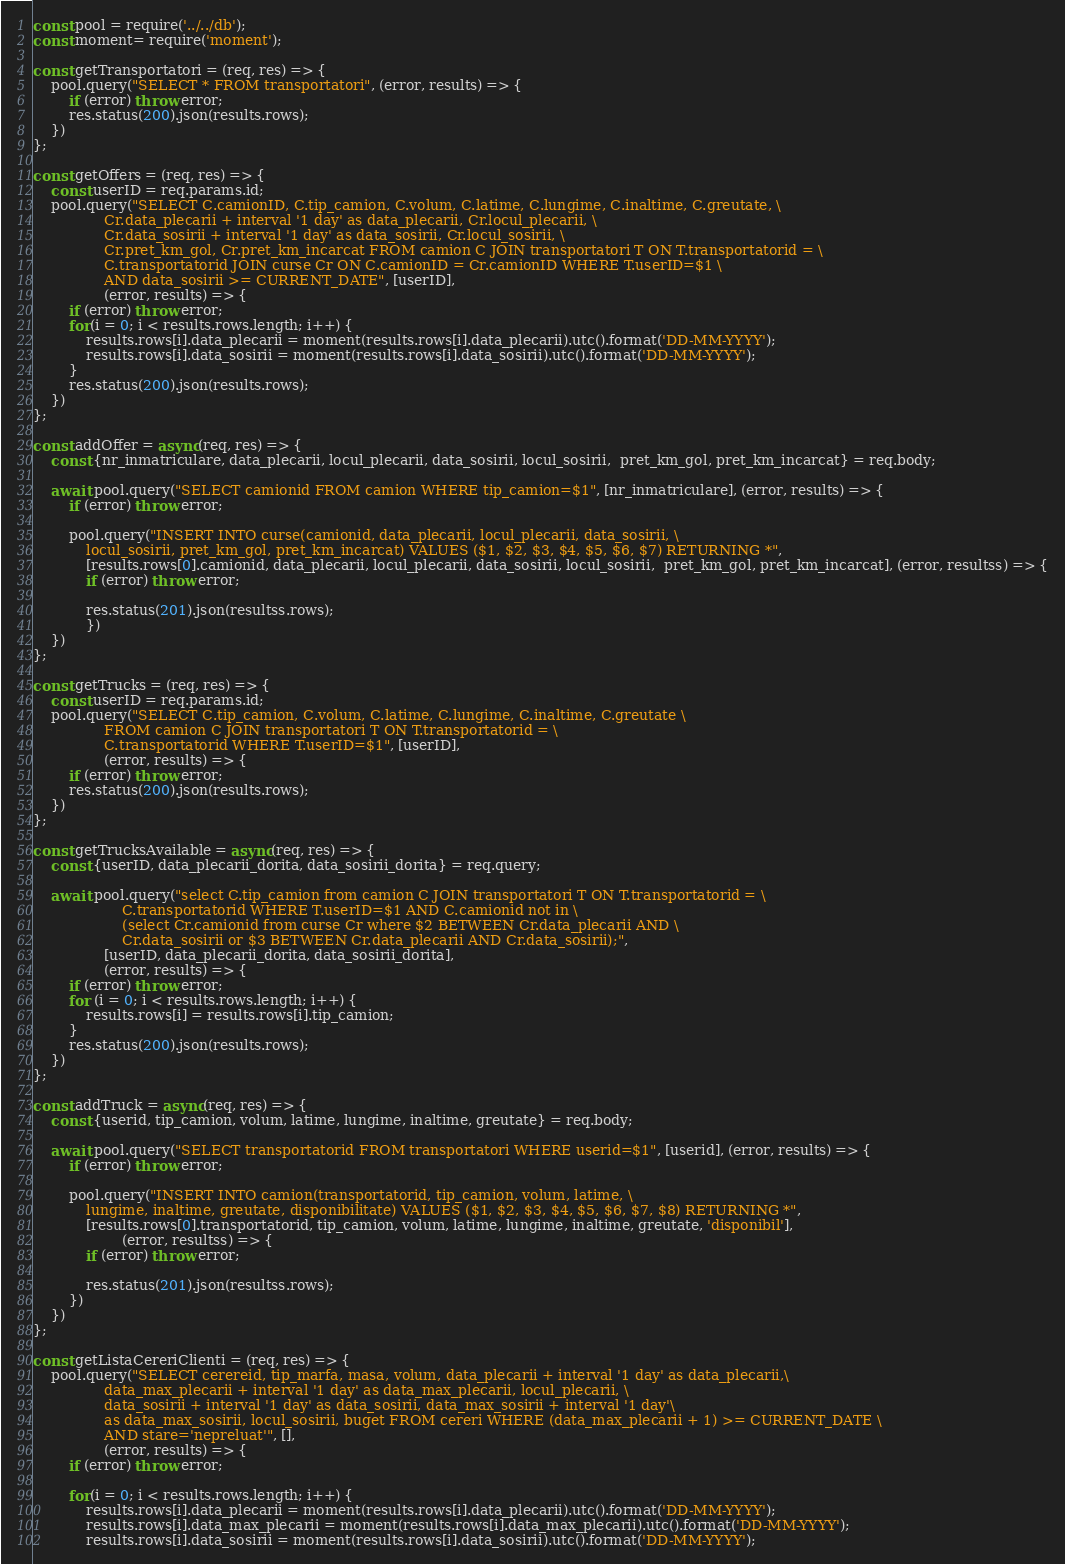Convert code to text. <code><loc_0><loc_0><loc_500><loc_500><_JavaScript_>const pool = require('../../db');
const moment= require('moment');

const getTransportatori = (req, res) => {
    pool.query("SELECT * FROM transportatori", (error, results) => {
        if (error) throw error;
        res.status(200).json(results.rows);
    })
};

const getOffers = (req, res) => {
    const userID = req.params.id;
    pool.query("SELECT C.camionID, C.tip_camion, C.volum, C.latime, C.lungime, C.inaltime, C.greutate, \
                Cr.data_plecarii + interval '1 day' as data_plecarii, Cr.locul_plecarii, \
                Cr.data_sosirii + interval '1 day' as data_sosirii, Cr.locul_sosirii, \
                Cr.pret_km_gol, Cr.pret_km_incarcat FROM camion C JOIN transportatori T ON T.transportatorid = \
                C.transportatorid JOIN curse Cr ON C.camionID = Cr.camionID WHERE T.userID=$1 \
                AND data_sosirii >= CURRENT_DATE", [userID], 
                (error, results) => {
        if (error) throw error;
        for(i = 0; i < results.rows.length; i++) {
            results.rows[i].data_plecarii = moment(results.rows[i].data_plecarii).utc().format('DD-MM-YYYY');
            results.rows[i].data_sosirii = moment(results.rows[i].data_sosirii).utc().format('DD-MM-YYYY');
        }
        res.status(200).json(results.rows);
    })
};

const addOffer = async(req, res) => {
    const {nr_inmatriculare, data_plecarii, locul_plecarii, data_sosirii, locul_sosirii,  pret_km_gol, pret_km_incarcat} = req.body;

    await pool.query("SELECT camionid FROM camion WHERE tip_camion=$1", [nr_inmatriculare], (error, results) => {
        if (error) throw error;

        pool.query("INSERT INTO curse(camionid, data_plecarii, locul_plecarii, data_sosirii, \
            locul_sosirii, pret_km_gol, pret_km_incarcat) VALUES ($1, $2, $3, $4, $5, $6, $7) RETURNING *",
            [results.rows[0].camionid, data_plecarii, locul_plecarii, data_sosirii, locul_sosirii,  pret_km_gol, pret_km_incarcat], (error, resultss) => {
            if (error) throw error;

            res.status(201).json(resultss.rows);
            })
    })
};

const getTrucks = (req, res) => {
    const userID = req.params.id;
    pool.query("SELECT C.tip_camion, C.volum, C.latime, C.lungime, C.inaltime, C.greutate \
                FROM camion C JOIN transportatori T ON T.transportatorid = \
                C.transportatorid WHERE T.userID=$1", [userID], 
                (error, results) => {
        if (error) throw error;
        res.status(200).json(results.rows);
    })
};

const getTrucksAvailable = async(req, res) => {
    const {userID, data_plecarii_dorita, data_sosirii_dorita} = req.query;

    await pool.query("select C.tip_camion from camion C JOIN transportatori T ON T.transportatorid = \
                    C.transportatorid WHERE T.userID=$1 AND C.camionid not in \
                    (select Cr.camionid from curse Cr where $2 BETWEEN Cr.data_plecarii AND \
                    Cr.data_sosirii or $3 BETWEEN Cr.data_plecarii AND Cr.data_sosirii);",
                [userID, data_plecarii_dorita, data_sosirii_dorita],
                (error, results) => {
        if (error) throw error;
        for (i = 0; i < results.rows.length; i++) {
            results.rows[i] = results.rows[i].tip_camion;
        }
        res.status(200).json(results.rows);
    })
};

const addTruck = async(req, res) => {
    const {userid, tip_camion, volum, latime, lungime, inaltime, greutate} = req.body;
    
    await pool.query("SELECT transportatorid FROM transportatori WHERE userid=$1", [userid], (error, results) => {
        if (error) throw error;

        pool.query("INSERT INTO camion(transportatorid, tip_camion, volum, latime, \
            lungime, inaltime, greutate, disponibilitate) VALUES ($1, $2, $3, $4, $5, $6, $7, $8) RETURNING *",
            [results.rows[0].transportatorid, tip_camion, volum, latime, lungime, inaltime, greutate, 'disponibil'], 
                    (error, resultss) => {
            if (error) throw error;

            res.status(201).json(resultss.rows);
        })
    })
};

const getListaCereriClienti = (req, res) => {
    pool.query("SELECT cerereid, tip_marfa, masa, volum, data_plecarii + interval '1 day' as data_plecarii,\
                data_max_plecarii + interval '1 day' as data_max_plecarii, locul_plecarii, \
                data_sosirii + interval '1 day' as data_sosirii, data_max_sosirii + interval '1 day'\
                as data_max_sosirii, locul_sosirii, buget FROM cereri WHERE (data_max_plecarii + 1) >= CURRENT_DATE \
                AND stare='nepreluat'", [], 
                (error, results) => {
        if (error) throw error;

        for(i = 0; i < results.rows.length; i++) {
            results.rows[i].data_plecarii = moment(results.rows[i].data_plecarii).utc().format('DD-MM-YYYY');
            results.rows[i].data_max_plecarii = moment(results.rows[i].data_max_plecarii).utc().format('DD-MM-YYYY');
            results.rows[i].data_sosirii = moment(results.rows[i].data_sosirii).utc().format('DD-MM-YYYY');</code> 